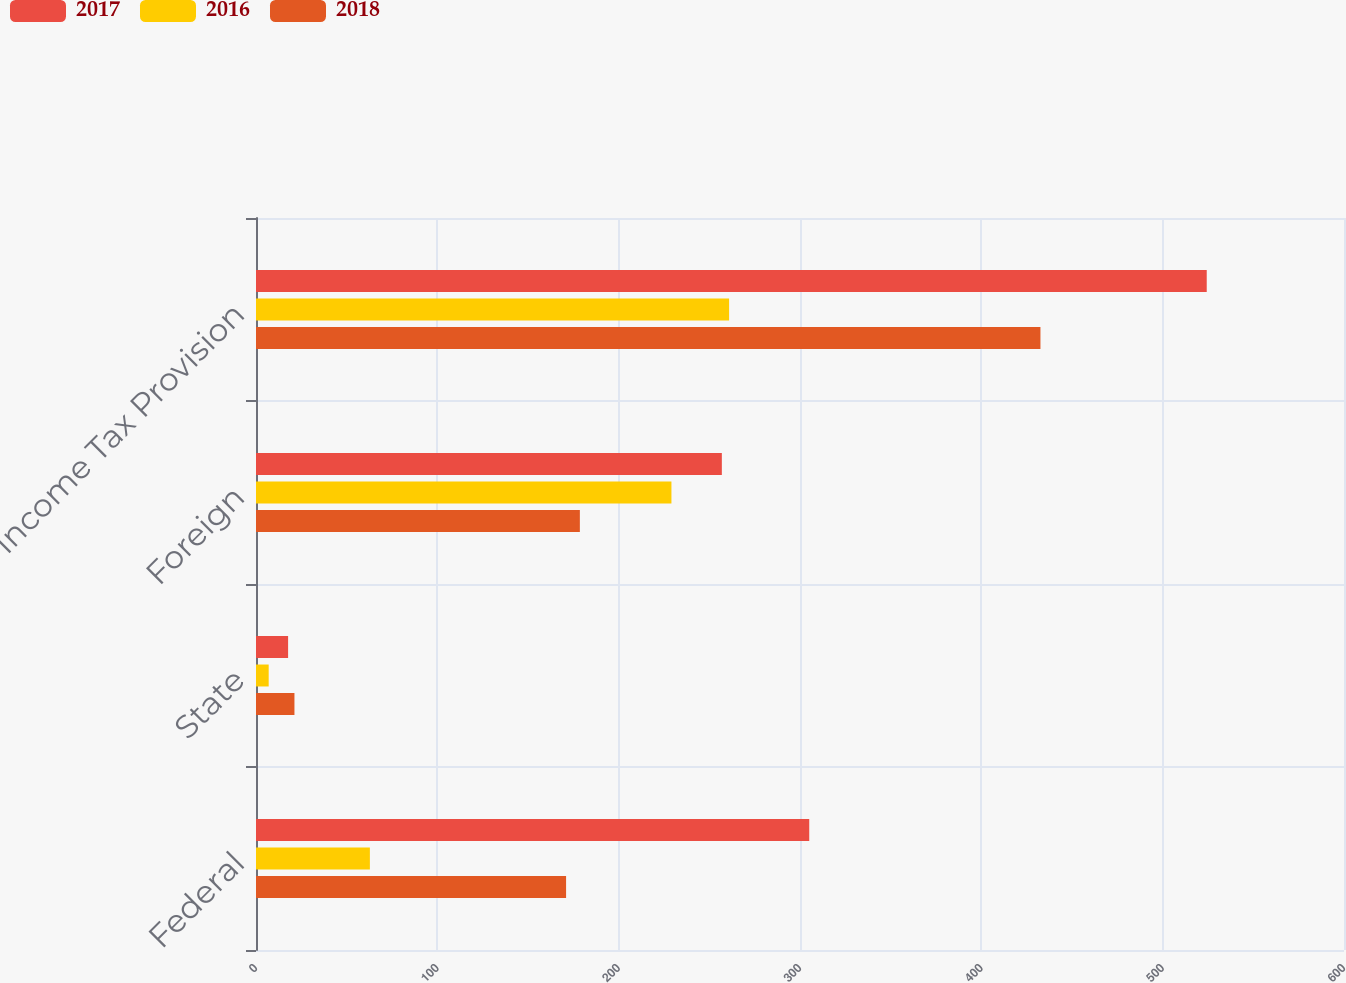Convert chart to OTSL. <chart><loc_0><loc_0><loc_500><loc_500><stacked_bar_chart><ecel><fcel>Federal<fcel>State<fcel>Foreign<fcel>Income Tax Provision<nl><fcel>2017<fcel>305.1<fcel>17.7<fcel>256.9<fcel>524.3<nl><fcel>2016<fcel>62.8<fcel>7<fcel>229.1<fcel>260.9<nl><fcel>2018<fcel>171<fcel>21.2<fcel>178.6<fcel>432.6<nl></chart> 